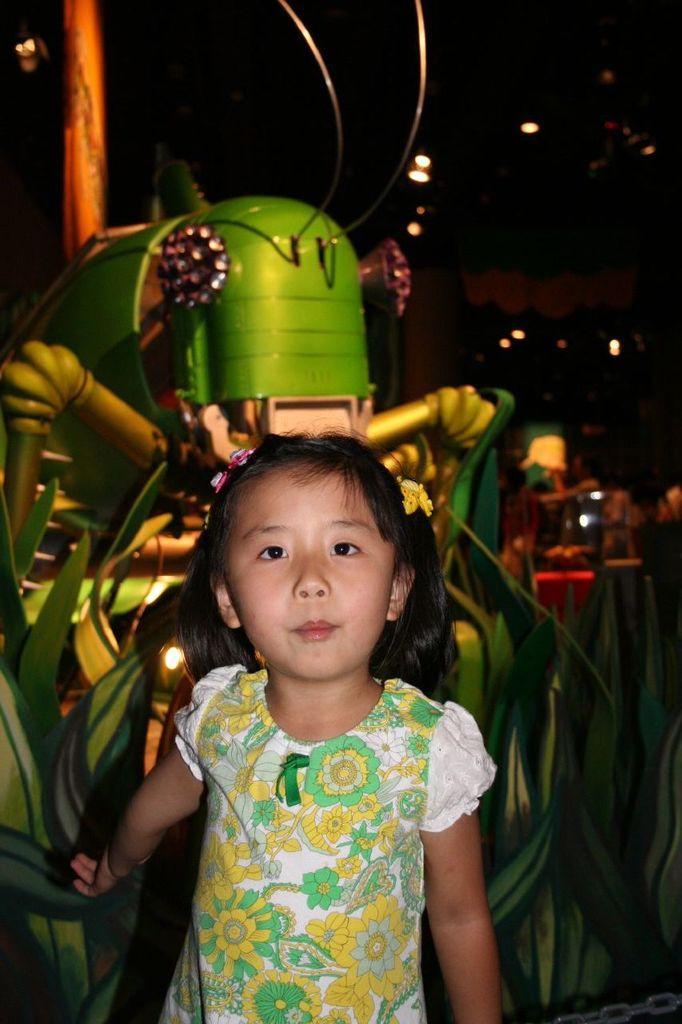Could you give a brief overview of what you see in this image? In this image I can see a small girl standing and posing for the picture in the center of the image. I can see some spider like object behind her and the background is dark. 